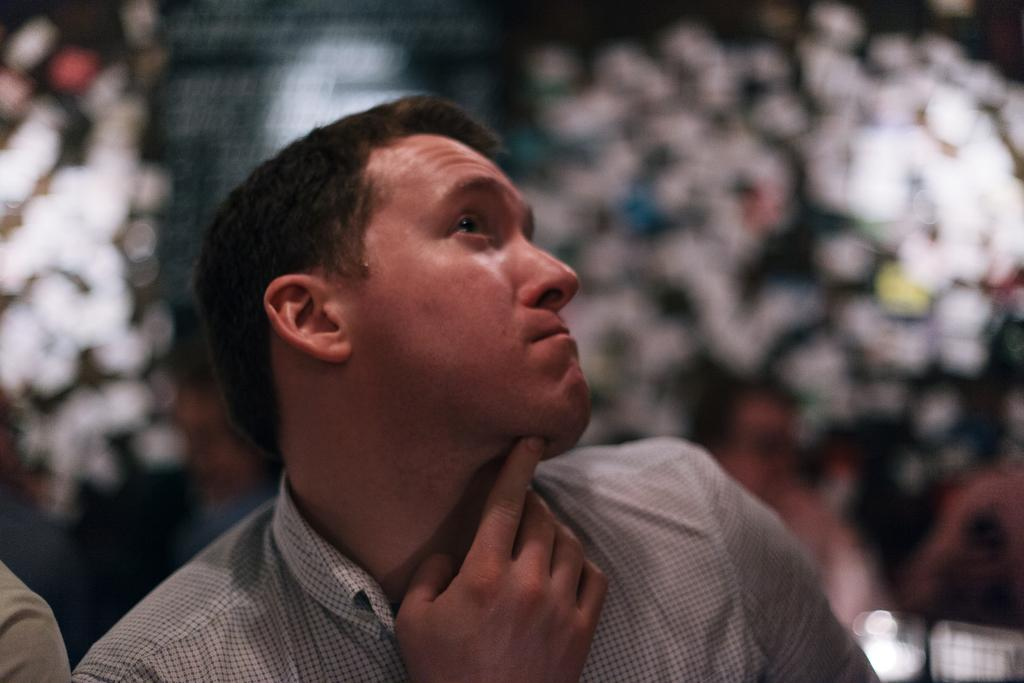What is the main subject in the image? There is a person in the image. Can you describe the background of the image? The background of the image is blurry. How many buildings can be seen in the image? There are no buildings visible in the image. What time of day is it in the image, based on the hour? The provided facts do not mention the time of day or any specific hour. 